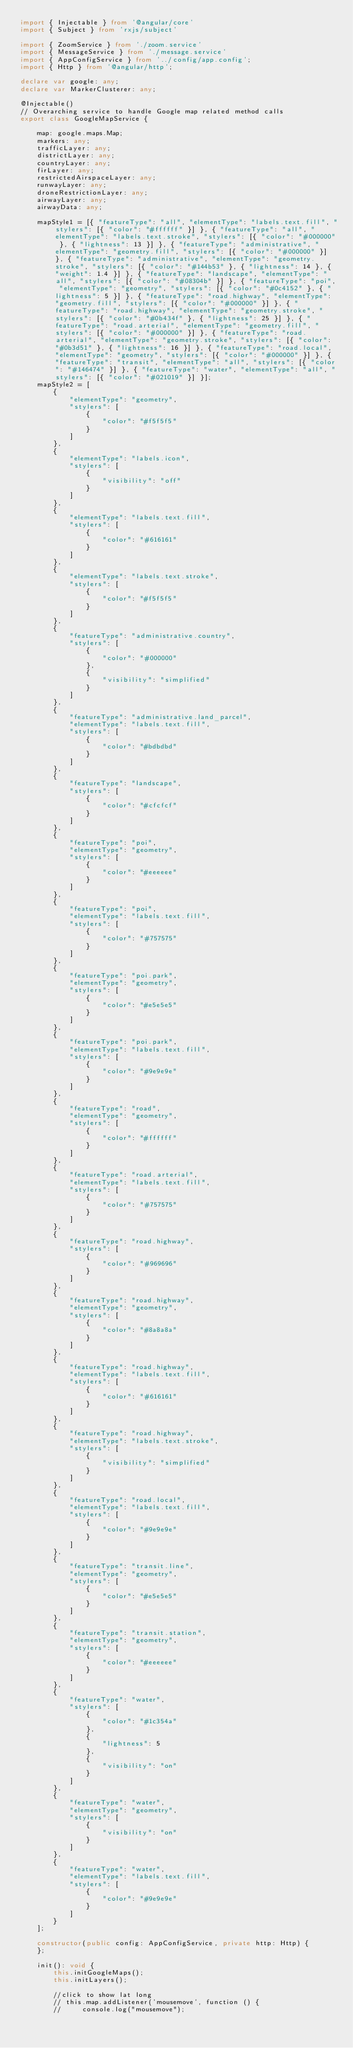Convert code to text. <code><loc_0><loc_0><loc_500><loc_500><_TypeScript_>import { Injectable } from '@angular/core'
import { Subject } from 'rxjs/subject'

import { ZoomService } from './zoom.service'
import { MessageService } from './message.service'
import { AppConfigService } from '../config/app.config';
import { Http } from '@angular/http';

declare var google: any;
declare var MarkerClusterer: any;

@Injectable()
// Overarching service to handle Google map related method calls
export class GoogleMapService {

    map: google.maps.Map;
    markers: any;
    trafficLayer: any;
    districtLayer: any;
    countryLayer: any;
    firLayer: any;
    restrictedAirspaceLayer: any;
    runwayLayer: any;
    droneRestrictionLayer: any;
    airwayLayer: any;
    airwayData: any;

    mapStyle1 = [{ "featureType": "all", "elementType": "labels.text.fill", "stylers": [{ "color": "#ffffff" }] }, { "featureType": "all", "elementType": "labels.text.stroke", "stylers": [{ "color": "#000000" }, { "lightness": 13 }] }, { "featureType": "administrative", "elementType": "geometry.fill", "stylers": [{ "color": "#000000" }] }, { "featureType": "administrative", "elementType": "geometry.stroke", "stylers": [{ "color": "#144b53" }, { "lightness": 14 }, { "weight": 1.4 }] }, { "featureType": "landscape", "elementType": "all", "stylers": [{ "color": "#08304b" }] }, { "featureType": "poi", "elementType": "geometry", "stylers": [{ "color": "#0c4152" }, { "lightness": 5 }] }, { "featureType": "road.highway", "elementType": "geometry.fill", "stylers": [{ "color": "#000000" }] }, { "featureType": "road.highway", "elementType": "geometry.stroke", "stylers": [{ "color": "#0b434f" }, { "lightness": 25 }] }, { "featureType": "road.arterial", "elementType": "geometry.fill", "stylers": [{ "color": "#000000" }] }, { "featureType": "road.arterial", "elementType": "geometry.stroke", "stylers": [{ "color": "#0b3d51" }, { "lightness": 16 }] }, { "featureType": "road.local", "elementType": "geometry", "stylers": [{ "color": "#000000" }] }, { "featureType": "transit", "elementType": "all", "stylers": [{ "color": "#146474" }] }, { "featureType": "water", "elementType": "all", "stylers": [{ "color": "#021019" }] }];
    mapStyle2 = [
        {
            "elementType": "geometry",
            "stylers": [
                {
                    "color": "#f5f5f5"
                }
            ]
        },
        {
            "elementType": "labels.icon",
            "stylers": [
                {
                    "visibility": "off"
                }
            ]
        },
        {
            "elementType": "labels.text.fill",
            "stylers": [
                {
                    "color": "#616161"
                }
            ]
        },
        {
            "elementType": "labels.text.stroke",
            "stylers": [
                {
                    "color": "#f5f5f5"
                }
            ]
        },
        {
            "featureType": "administrative.country",
            "stylers": [
                {
                    "color": "#000000"
                },
                {
                    "visibility": "simplified"
                }
            ]
        },
        {
            "featureType": "administrative.land_parcel",
            "elementType": "labels.text.fill",
            "stylers": [
                {
                    "color": "#bdbdbd"
                }
            ]
        },
        {
            "featureType": "landscape",
            "stylers": [
                {
                    "color": "#cfcfcf"
                }
            ]
        },
        {
            "featureType": "poi",
            "elementType": "geometry",
            "stylers": [
                {
                    "color": "#eeeeee"
                }
            ]
        },
        {
            "featureType": "poi",
            "elementType": "labels.text.fill",
            "stylers": [
                {
                    "color": "#757575"
                }
            ]
        },
        {
            "featureType": "poi.park",
            "elementType": "geometry",
            "stylers": [
                {
                    "color": "#e5e5e5"
                }
            ]
        },
        {
            "featureType": "poi.park",
            "elementType": "labels.text.fill",
            "stylers": [
                {
                    "color": "#9e9e9e"
                }
            ]
        },
        {
            "featureType": "road",
            "elementType": "geometry",
            "stylers": [
                {
                    "color": "#ffffff"
                }
            ]
        },
        {
            "featureType": "road.arterial",
            "elementType": "labels.text.fill",
            "stylers": [
                {
                    "color": "#757575"
                }
            ]
        },
        {
            "featureType": "road.highway",
            "stylers": [
                {
                    "color": "#969696"
                }
            ]
        },
        {
            "featureType": "road.highway",
            "elementType": "geometry",
            "stylers": [
                {
                    "color": "#8a8a8a"
                }
            ]
        },
        {
            "featureType": "road.highway",
            "elementType": "labels.text.fill",
            "stylers": [
                {
                    "color": "#616161"
                }
            ]
        },
        {
            "featureType": "road.highway",
            "elementType": "labels.text.stroke",
            "stylers": [
                {
                    "visibility": "simplified"
                }
            ]
        },
        {
            "featureType": "road.local",
            "elementType": "labels.text.fill",
            "stylers": [
                {
                    "color": "#9e9e9e"
                }
            ]
        },
        {
            "featureType": "transit.line",
            "elementType": "geometry",
            "stylers": [
                {
                    "color": "#e5e5e5"
                }
            ]
        },
        {
            "featureType": "transit.station",
            "elementType": "geometry",
            "stylers": [
                {
                    "color": "#eeeeee"
                }
            ]
        },
        {
            "featureType": "water",
            "stylers": [
                {
                    "color": "#1c354a"
                },
                {
                    "lightness": 5
                },
                {
                    "visibility": "on"
                }
            ]
        },
        {
            "featureType": "water",
            "elementType": "geometry",
            "stylers": [
                {
                    "visibility": "on"
                }
            ]
        },
        {
            "featureType": "water",
            "elementType": "labels.text.fill",
            "stylers": [
                {
                    "color": "#9e9e9e"
                }
            ]
        }
    ];

    constructor(public config: AppConfigService, private http: Http) {
    };

    init(): void {
        this.initGoogleMaps();
        this.initLayers();

        //click to show lat long
        // this.map.addListener('mousemove', function () {
        //     console.log("mousemove");</code> 